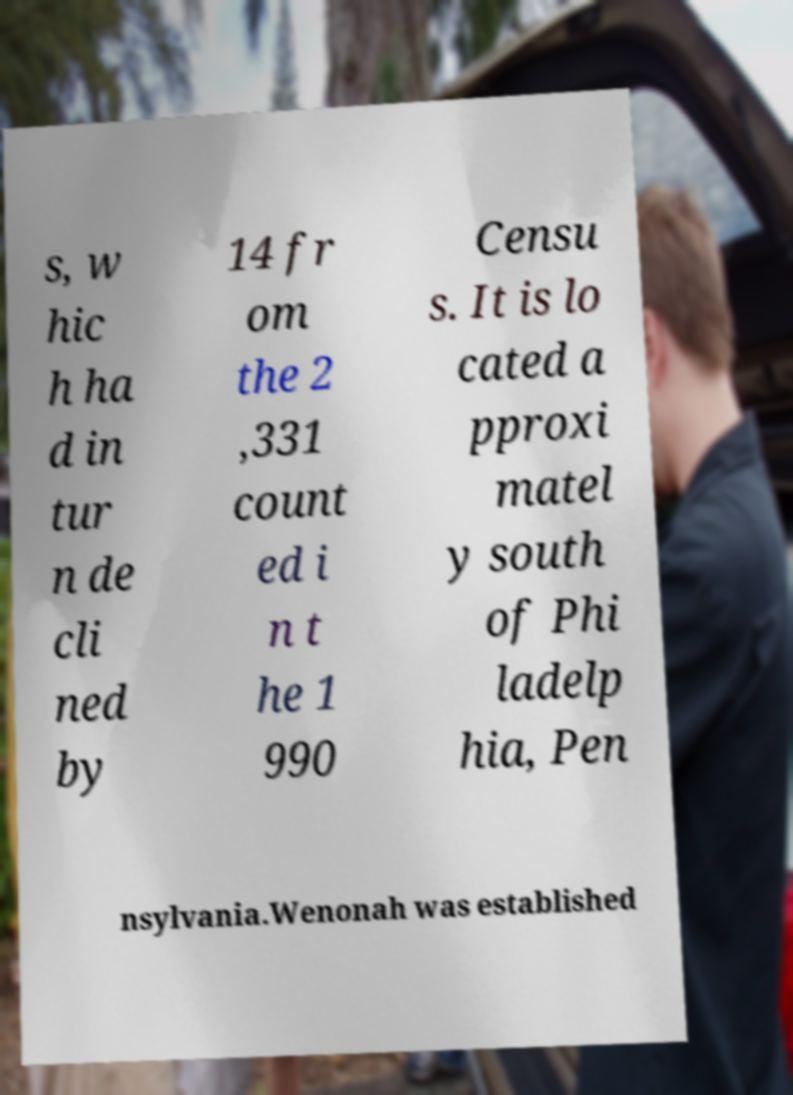What messages or text are displayed in this image? I need them in a readable, typed format. s, w hic h ha d in tur n de cli ned by 14 fr om the 2 ,331 count ed i n t he 1 990 Censu s. It is lo cated a pproxi matel y south of Phi ladelp hia, Pen nsylvania.Wenonah was established 